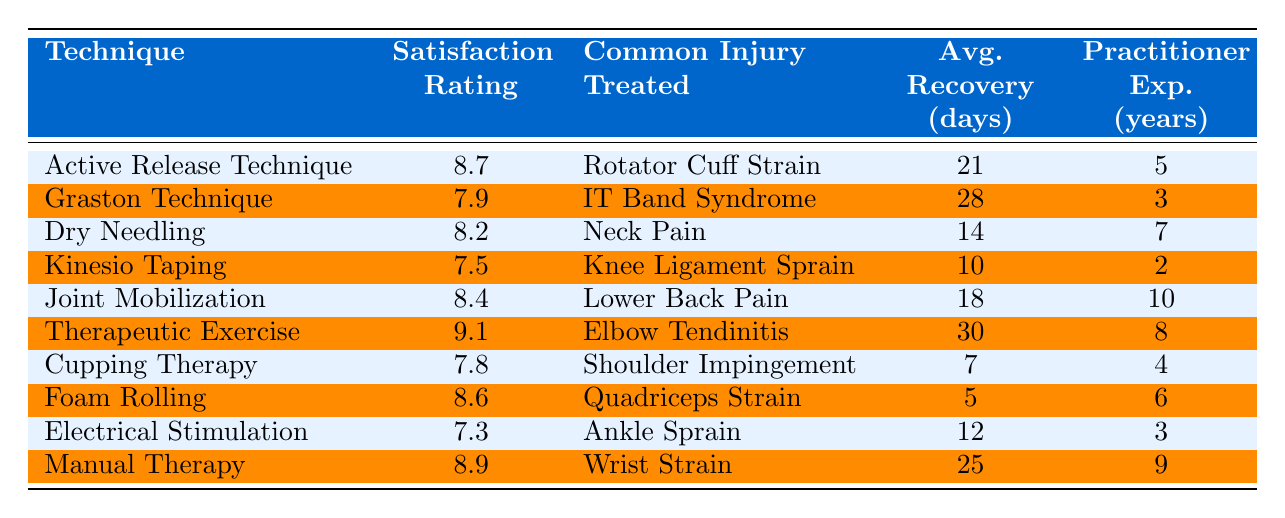What is the satisfaction rating for the Graston Technique? The Graston Technique has a satisfaction rating listed in the table of 7.9.
Answer: 7.9 Which technique has the highest satisfaction rating? By comparing the satisfaction ratings in the table, Therapeutic Exercise has the highest rating at 9.1.
Answer: Therapeutic Exercise What is the average recovery time for Dry Needling? The table shows that Dry Needling has an average recovery time of 14 days.
Answer: 14 days Is the average recovery time longer for the Graston Technique compared to Kinesio Taping? The average recovery time for Graston Technique is 28 days, while for Kinesio Taping it is 10 days. Since 28 is greater than 10, the answer is yes.
Answer: Yes What is the satisfaction rating difference between Active Release Technique and Manual Therapy? Active Release Technique has a satisfaction rating of 8.7, and Manual Therapy has 8.9. The difference is 8.9 - 8.7 = 0.2.
Answer: 0.2 Which technique has the lowest average recovery time? The table indicates that Foam Rolling has the lowest average recovery time of 5 days among all listed techniques.
Answer: Foam Rolling How many techniques have a satisfaction rating above 8.0? The techniques with satisfaction ratings above 8.0 are: Active Release Technique (8.7), Dry Needling (8.2), Joint Mobilization (8.4), Therapeutic Exercise (9.1), Foam Rolling (8.6), and Manual Therapy (8.9). This totals 6 techniques.
Answer: 6 Is the practitioner experience for Cupping Therapy greater than the average for all techniques? The average practitioner experience across all techniques is calculated as (5 + 3 + 7 + 2 + 10 + 8 + 4 + 6 + 3 + 9) / 10 = 5.7 years. Cupping Therapy has 4 years of experience, which is less than the average.
Answer: No What is the sum of the satisfaction ratings for techniques that treat shoulder-related injuries? The techniques treating shoulder-related injuries are Active Release Technique (8.7) and Cupping Therapy (7.8). Their sum is 8.7 + 7.8 = 16.5.
Answer: 16.5 How does the average recovery time of Joint Mobilization compare to that of Electrical Stimulation? Joint Mobilization has an average recovery time of 18 days, while Electrical Stimulation has 12 days. Since 18 is greater than 12, Joint Mobilization has longer recovery time.
Answer: Longer What is the highest average recovery time listed for any technique? The highest average recovery time listed is 30 days for Therapeutic Exercise.
Answer: 30 days 